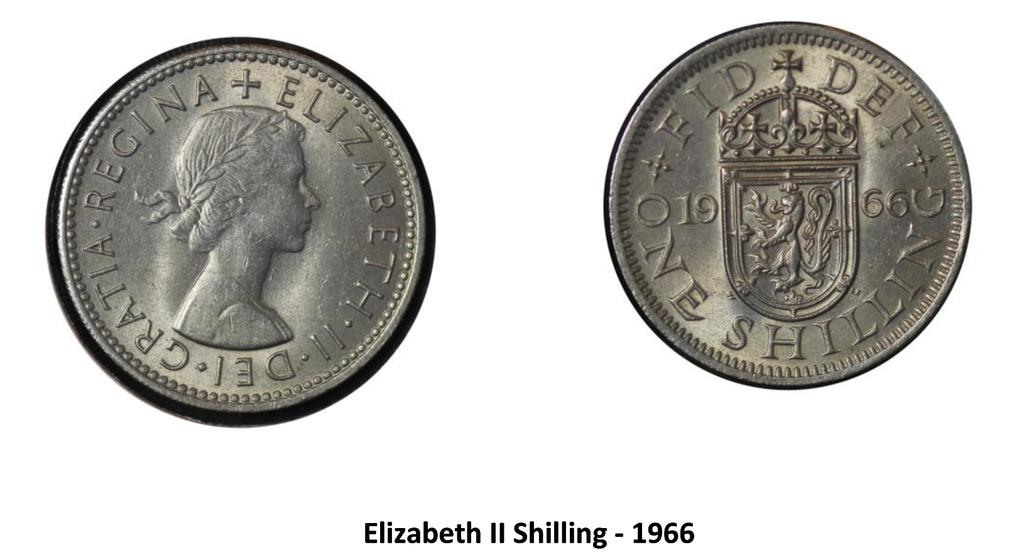<image>
Offer a succinct explanation of the picture presented. The front and back of the Elizabeth II Shilling from 1966. 